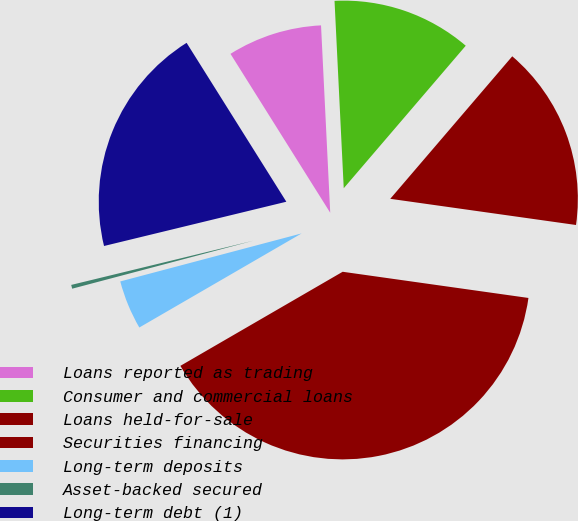Convert chart. <chart><loc_0><loc_0><loc_500><loc_500><pie_chart><fcel>Loans reported as trading<fcel>Consumer and commercial loans<fcel>Loans held-for-sale<fcel>Securities financing<fcel>Long-term deposits<fcel>Asset-backed secured<fcel>Long-term debt (1)<nl><fcel>8.14%<fcel>12.05%<fcel>15.96%<fcel>39.41%<fcel>4.24%<fcel>0.33%<fcel>19.87%<nl></chart> 